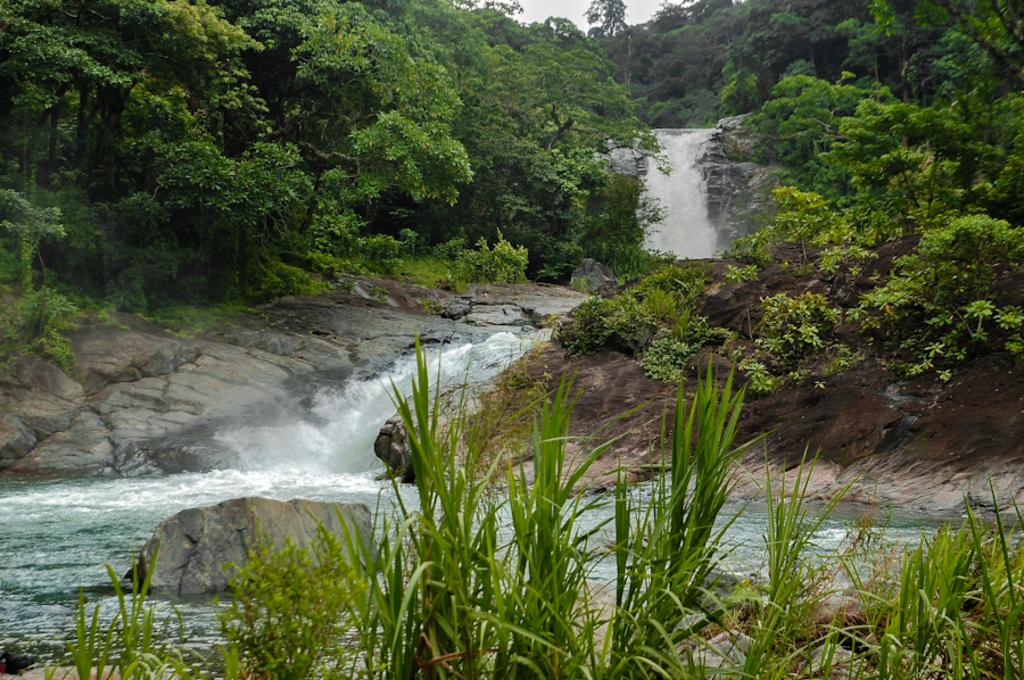What type of natural features can be seen in the image? There are trees, rocks, and a waterfall in the image. What type of vegetation is present in the image? There are plants in the image. What is visible at the top of the image? The sky is visible at the top of the image. What grade does the science teacher give for the soap experiment in the image? There is no soap, science teacher, or experiment present in the image. 